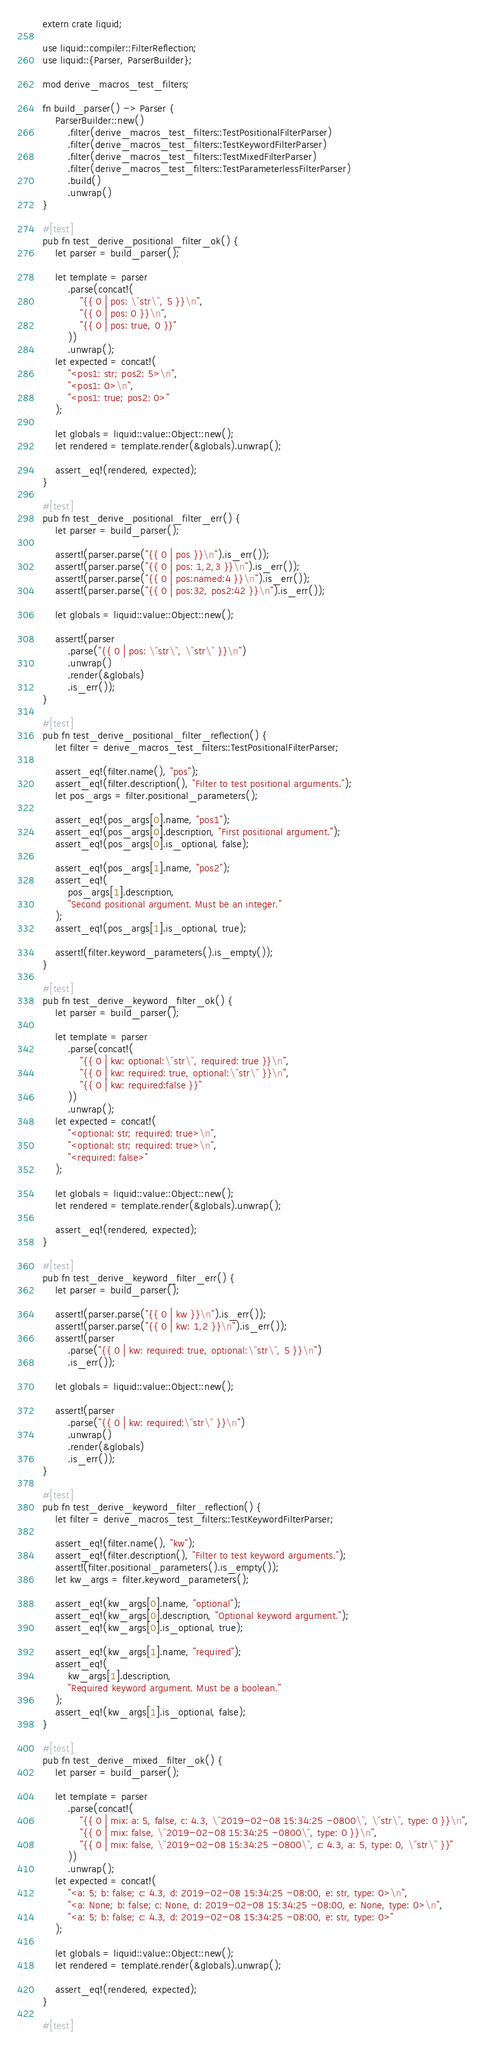Convert code to text. <code><loc_0><loc_0><loc_500><loc_500><_Rust_>extern crate liquid;

use liquid::compiler::FilterReflection;
use liquid::{Parser, ParserBuilder};

mod derive_macros_test_filters;

fn build_parser() -> Parser {
    ParserBuilder::new()
        .filter(derive_macros_test_filters::TestPositionalFilterParser)
        .filter(derive_macros_test_filters::TestKeywordFilterParser)
        .filter(derive_macros_test_filters::TestMixedFilterParser)
        .filter(derive_macros_test_filters::TestParameterlessFilterParser)
        .build()
        .unwrap()
}

#[test]
pub fn test_derive_positional_filter_ok() {
    let parser = build_parser();

    let template = parser
        .parse(concat!(
            "{{ 0 | pos: \"str\", 5 }}\n",
            "{{ 0 | pos: 0 }}\n",
            "{{ 0 | pos: true, 0 }}"
        ))
        .unwrap();
    let expected = concat!(
        "<pos1: str; pos2: 5>\n",
        "<pos1: 0>\n",
        "<pos1: true; pos2: 0>"
    );

    let globals = liquid::value::Object::new();
    let rendered = template.render(&globals).unwrap();

    assert_eq!(rendered, expected);
}

#[test]
pub fn test_derive_positional_filter_err() {
    let parser = build_parser();

    assert!(parser.parse("{{ 0 | pos }}\n").is_err());
    assert!(parser.parse("{{ 0 | pos: 1,2,3 }}\n").is_err());
    assert!(parser.parse("{{ 0 | pos:named:4 }}\n").is_err());
    assert!(parser.parse("{{ 0 | pos:32, pos2:42 }}\n").is_err());

    let globals = liquid::value::Object::new();

    assert!(parser
        .parse("{{ 0 | pos: \"str\", \"str\" }}\n")
        .unwrap()
        .render(&globals)
        .is_err());
}

#[test]
pub fn test_derive_positional_filter_reflection() {
    let filter = derive_macros_test_filters::TestPositionalFilterParser;

    assert_eq!(filter.name(), "pos");
    assert_eq!(filter.description(), "Filter to test positional arguments.");
    let pos_args = filter.positional_parameters();

    assert_eq!(pos_args[0].name, "pos1");
    assert_eq!(pos_args[0].description, "First positional argument.");
    assert_eq!(pos_args[0].is_optional, false);

    assert_eq!(pos_args[1].name, "pos2");
    assert_eq!(
        pos_args[1].description,
        "Second positional argument. Must be an integer."
    );
    assert_eq!(pos_args[1].is_optional, true);

    assert!(filter.keyword_parameters().is_empty());
}

#[test]
pub fn test_derive_keyword_filter_ok() {
    let parser = build_parser();

    let template = parser
        .parse(concat!(
            "{{ 0 | kw: optional:\"str\", required: true }}\n",
            "{{ 0 | kw: required: true, optional:\"str\" }}\n",
            "{{ 0 | kw: required:false }}"
        ))
        .unwrap();
    let expected = concat!(
        "<optional: str; required: true>\n",
        "<optional: str; required: true>\n",
        "<required: false>"
    );

    let globals = liquid::value::Object::new();
    let rendered = template.render(&globals).unwrap();

    assert_eq!(rendered, expected);
}

#[test]
pub fn test_derive_keyword_filter_err() {
    let parser = build_parser();

    assert!(parser.parse("{{ 0 | kw }}\n").is_err());
    assert!(parser.parse("{{ 0 | kw: 1,2 }}\n").is_err());
    assert!(parser
        .parse("{{ 0 | kw: required: true, optional:\"str\", 5 }}\n")
        .is_err());

    let globals = liquid::value::Object::new();

    assert!(parser
        .parse("{{ 0 | kw: required:\"str\" }}\n")
        .unwrap()
        .render(&globals)
        .is_err());
}

#[test]
pub fn test_derive_keyword_filter_reflection() {
    let filter = derive_macros_test_filters::TestKeywordFilterParser;

    assert_eq!(filter.name(), "kw");
    assert_eq!(filter.description(), "Filter to test keyword arguments.");
    assert!(filter.positional_parameters().is_empty());
    let kw_args = filter.keyword_parameters();

    assert_eq!(kw_args[0].name, "optional");
    assert_eq!(kw_args[0].description, "Optional keyword argument.");
    assert_eq!(kw_args[0].is_optional, true);

    assert_eq!(kw_args[1].name, "required");
    assert_eq!(
        kw_args[1].description,
        "Required keyword argument. Must be a boolean."
    );
    assert_eq!(kw_args[1].is_optional, false);
}

#[test]
pub fn test_derive_mixed_filter_ok() {
    let parser = build_parser();

    let template = parser
        .parse(concat!(
            "{{ 0 | mix: a: 5, false, c: 4.3, \"2019-02-08 15:34:25 -0800\", \"str\", type: 0 }}\n",
            "{{ 0 | mix: false, \"2019-02-08 15:34:25 -0800\", type: 0 }}\n",
            "{{ 0 | mix: false, \"2019-02-08 15:34:25 -0800\", c: 4.3, a: 5, type: 0, \"str\" }}"
        ))
        .unwrap();
    let expected = concat!(
        "<a: 5; b: false; c: 4.3, d: 2019-02-08 15:34:25 -08:00, e: str, type: 0>\n",
        "<a: None; b: false; c: None, d: 2019-02-08 15:34:25 -08:00, e: None, type: 0>\n",
        "<a: 5; b: false; c: 4.3, d: 2019-02-08 15:34:25 -08:00, e: str, type: 0>"
    );

    let globals = liquid::value::Object::new();
    let rendered = template.render(&globals).unwrap();

    assert_eq!(rendered, expected);
}

#[test]</code> 